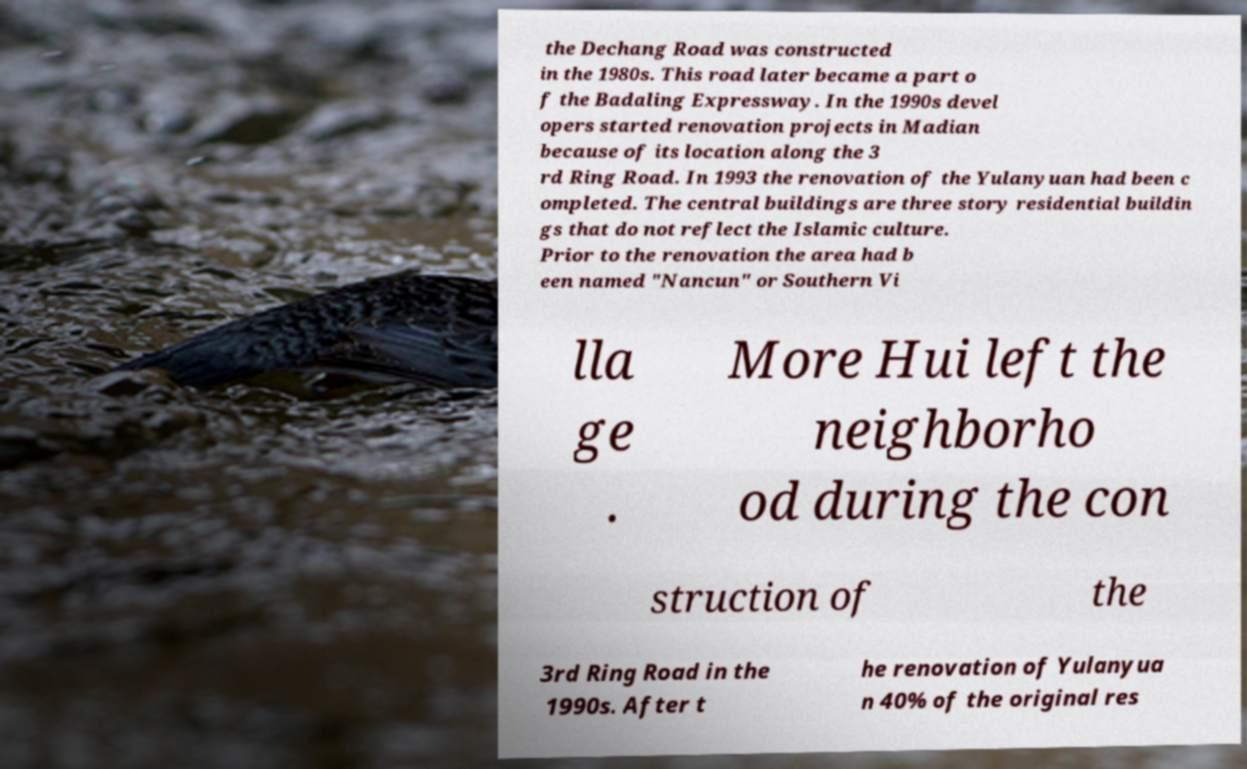For documentation purposes, I need the text within this image transcribed. Could you provide that? the Dechang Road was constructed in the 1980s. This road later became a part o f the Badaling Expressway. In the 1990s devel opers started renovation projects in Madian because of its location along the 3 rd Ring Road. In 1993 the renovation of the Yulanyuan had been c ompleted. The central buildings are three story residential buildin gs that do not reflect the Islamic culture. Prior to the renovation the area had b een named "Nancun" or Southern Vi lla ge . More Hui left the neighborho od during the con struction of the 3rd Ring Road in the 1990s. After t he renovation of Yulanyua n 40% of the original res 